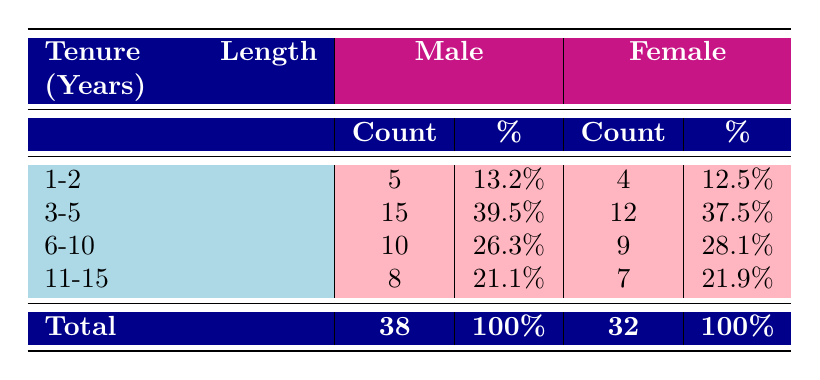What is the total number of promotions for males? To find the total number of promotions for males, sum the promotions from all tenure lengths: 5 + 15 + 10 + 8 = 38.
Answer: 38 What percentage of male promotions were earned by those with 3-5 years of tenure? For males, there are 15 promotions in the 3-5 tenure length. The total promotions for males is 38. So the percentage is (15/38) * 100 = 39.5%.
Answer: 39.5% Which gender has a higher total number of promotions? The total number of promotions for males is 38, while for females, it is 32. Therefore, males have more promotions.
Answer: Yes What are the average promotions per gender for each tenure length? To calculate the average, total promotions are divided by the number of data points per gender (4 for each). For males: (5 + 15 + 10 + 8) / 4 = 9.25 and for females: (4 + 12 + 9 + 7) / 4 = 8. The averages are 9.25 for males and 8 for females.
Answer: Males: 9.25, Females: 8 How many more promotions did males receive in the 3-5 year tenure compared to females in the same category? Males received 15 promotions and females received 12 promotions in the 3-5 years category. The difference is 15 - 12 = 3.
Answer: 3 What is the percentage of total promotions that females with 6-10 years of tenure received? Females with 6-10 years of tenure received 9 promotions, and the total promotions for females is 32. The percentage is (9/32) * 100 = 28.1%.
Answer: 28.1% Is the percentage of promotions for females in the 1-2 year tenure greater than that of males? In the 1-2 year tenure, females have 12.5% and males have 13.2%. Since 12.5% is less than 13.2%, the statement is false.
Answer: No What is the combined percentage of promotions for both genders in the 11-15 year tenure? For the 11-15 year tenure, males have 21.1% and females have 21.9%. Adding these gives 21.1% + 21.9% = 43%.
Answer: 43% 